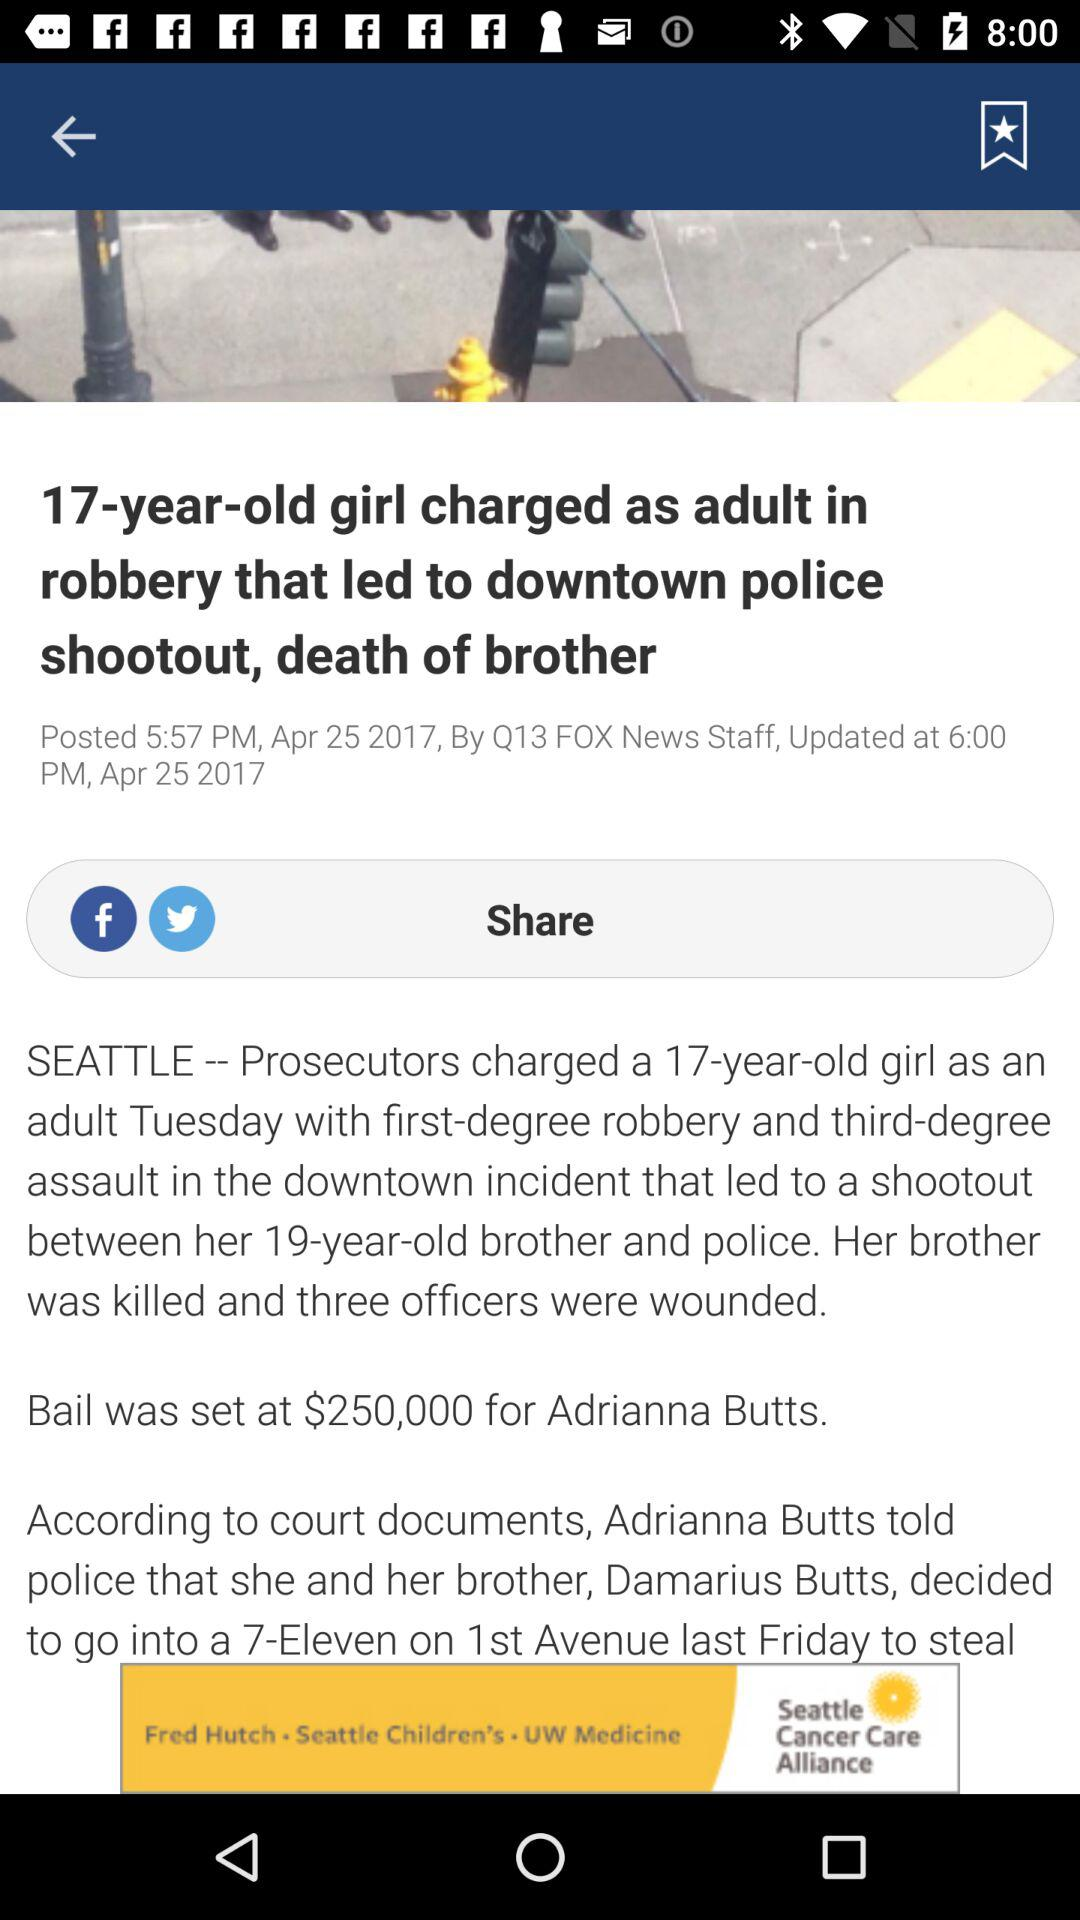When was the news posted? The news was posted on April 25, 2017 at 5:57 PM. 